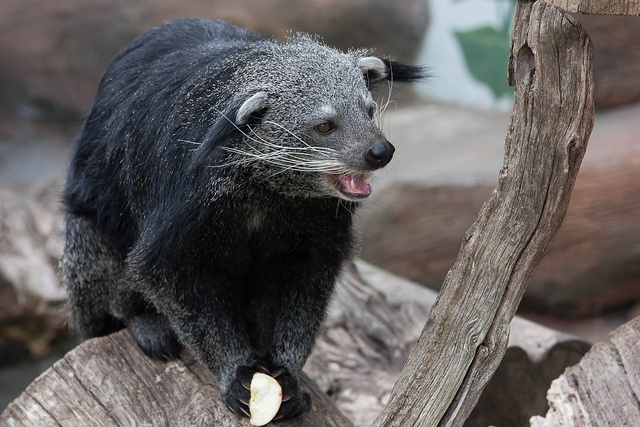Describe the objects in this image and their specific colors. I can see bear in gray, black, and darkgray tones and apple in gray, ivory, beige, and black tones in this image. 